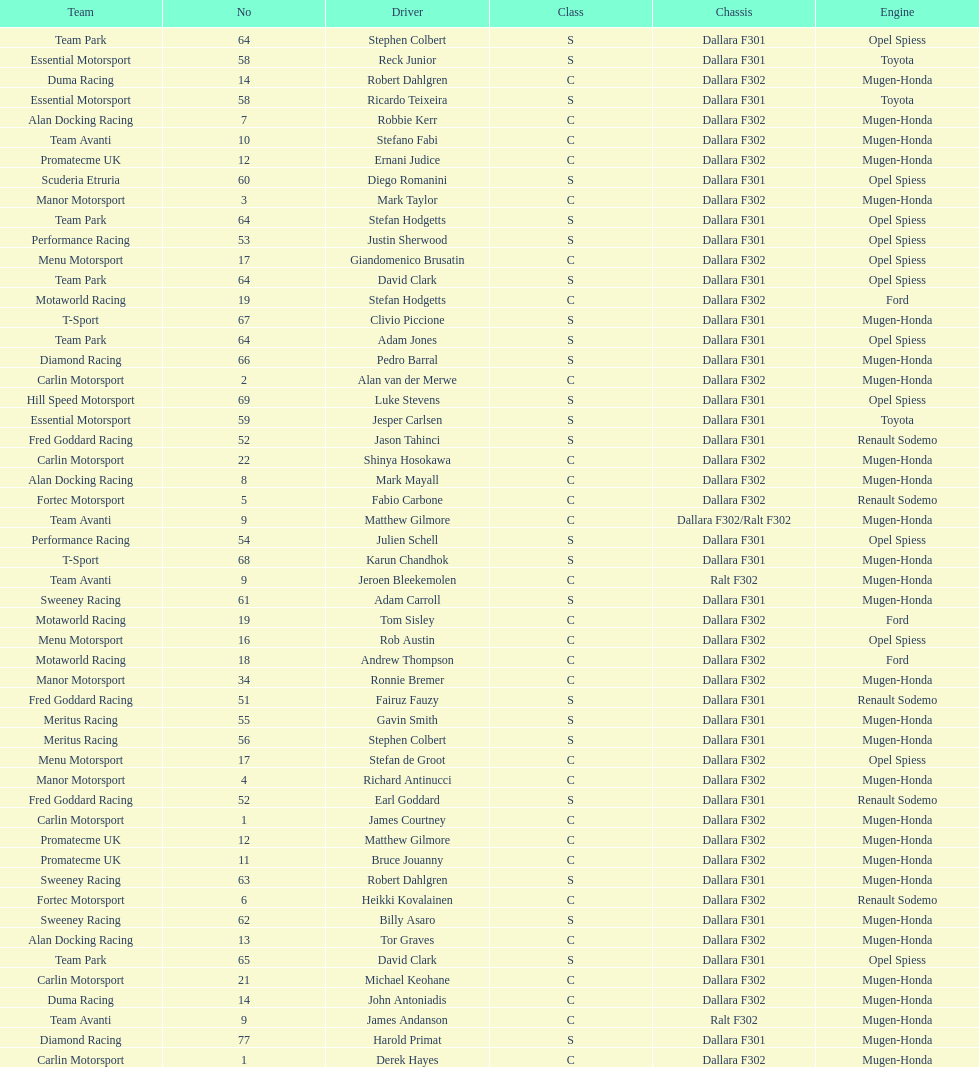Which engine was used the most by teams this season? Mugen-Honda. 